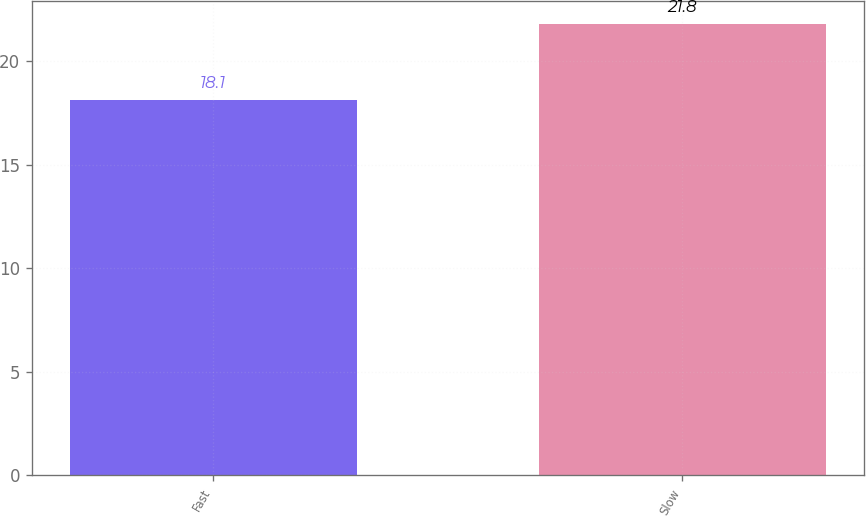Convert chart. <chart><loc_0><loc_0><loc_500><loc_500><bar_chart><fcel>Fast<fcel>Slow<nl><fcel>18.1<fcel>21.8<nl></chart> 